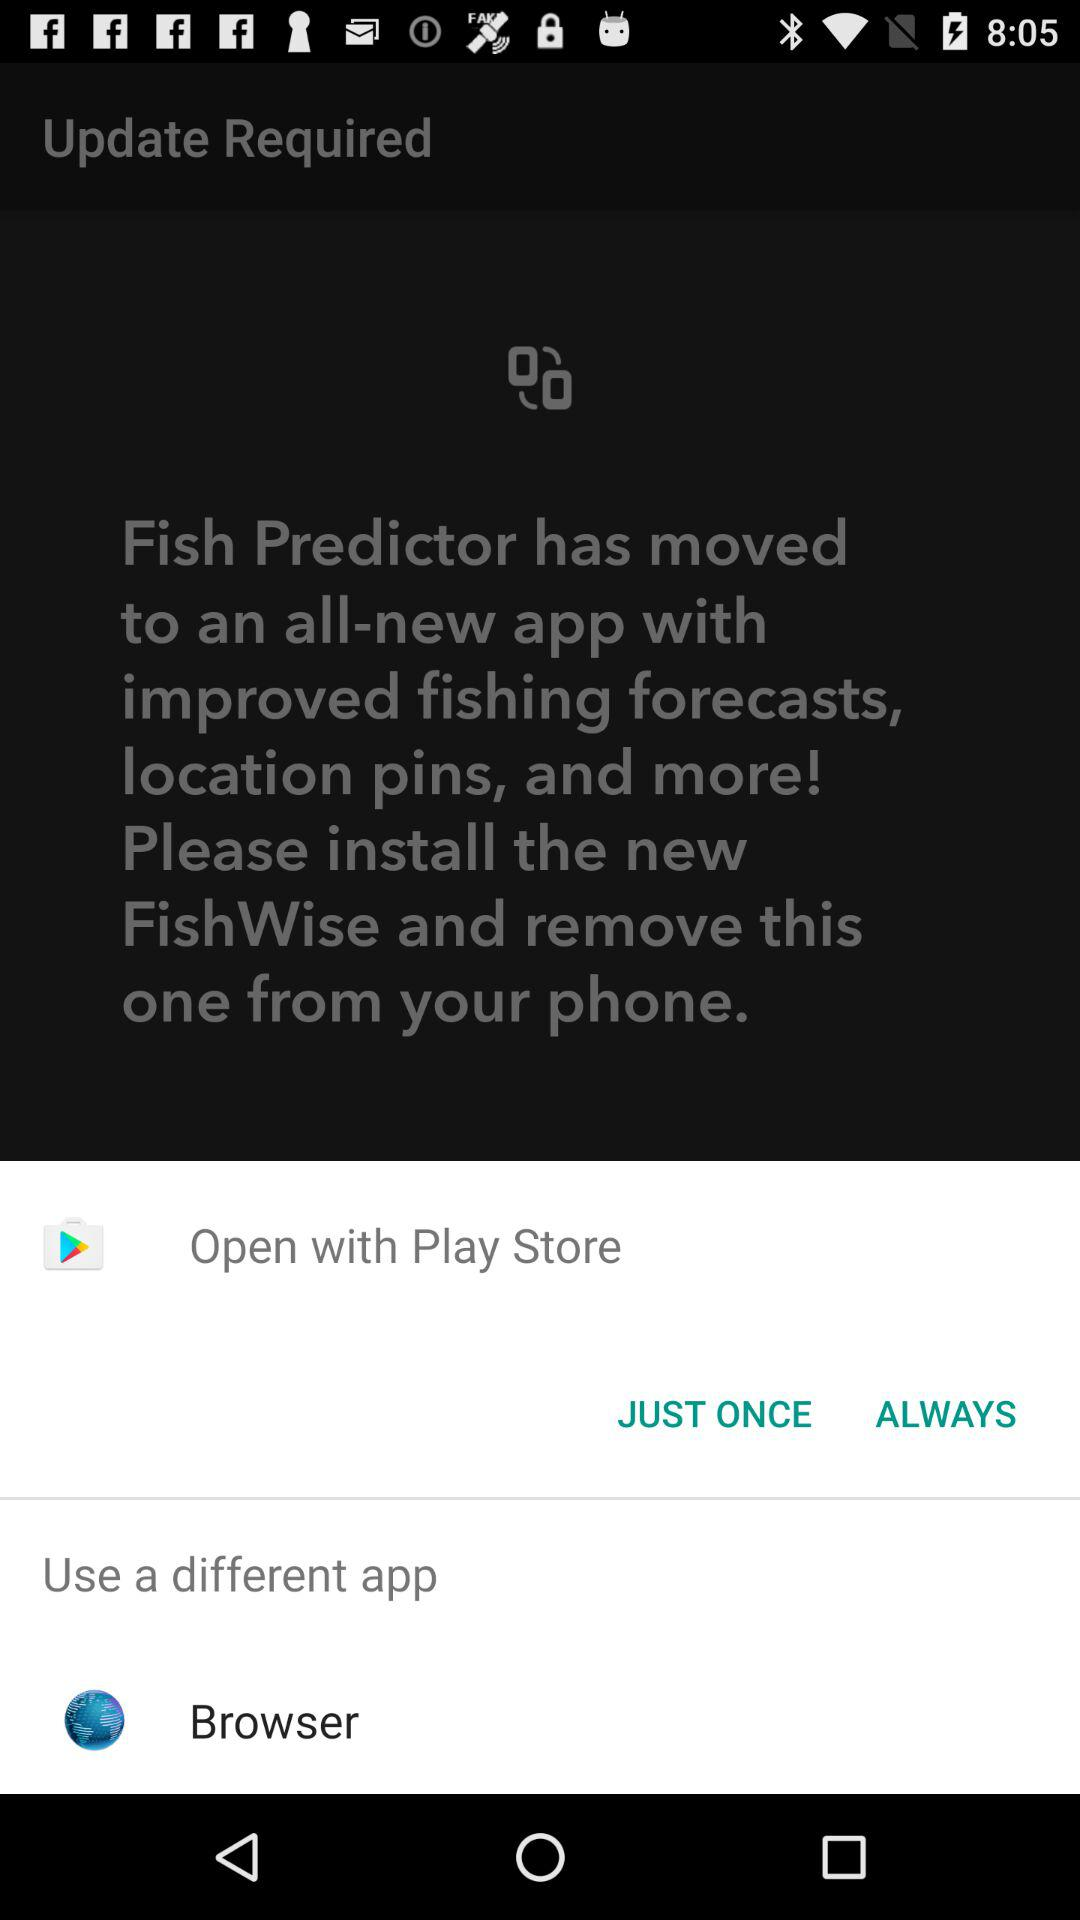What are the options to open it? The options to open it are "Play Store" and "Browser". 